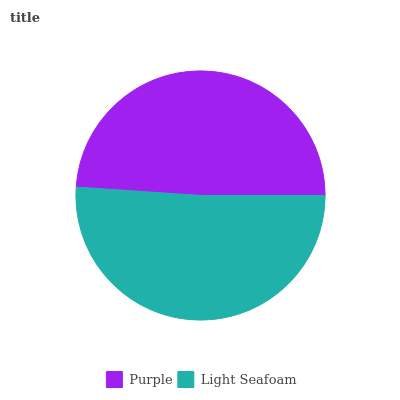Is Purple the minimum?
Answer yes or no. Yes. Is Light Seafoam the maximum?
Answer yes or no. Yes. Is Light Seafoam the minimum?
Answer yes or no. No. Is Light Seafoam greater than Purple?
Answer yes or no. Yes. Is Purple less than Light Seafoam?
Answer yes or no. Yes. Is Purple greater than Light Seafoam?
Answer yes or no. No. Is Light Seafoam less than Purple?
Answer yes or no. No. Is Light Seafoam the high median?
Answer yes or no. Yes. Is Purple the low median?
Answer yes or no. Yes. Is Purple the high median?
Answer yes or no. No. Is Light Seafoam the low median?
Answer yes or no. No. 